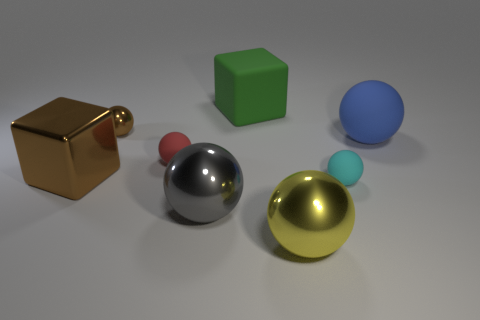The other tiny rubber object that is the same shape as the small red matte object is what color? cyan 